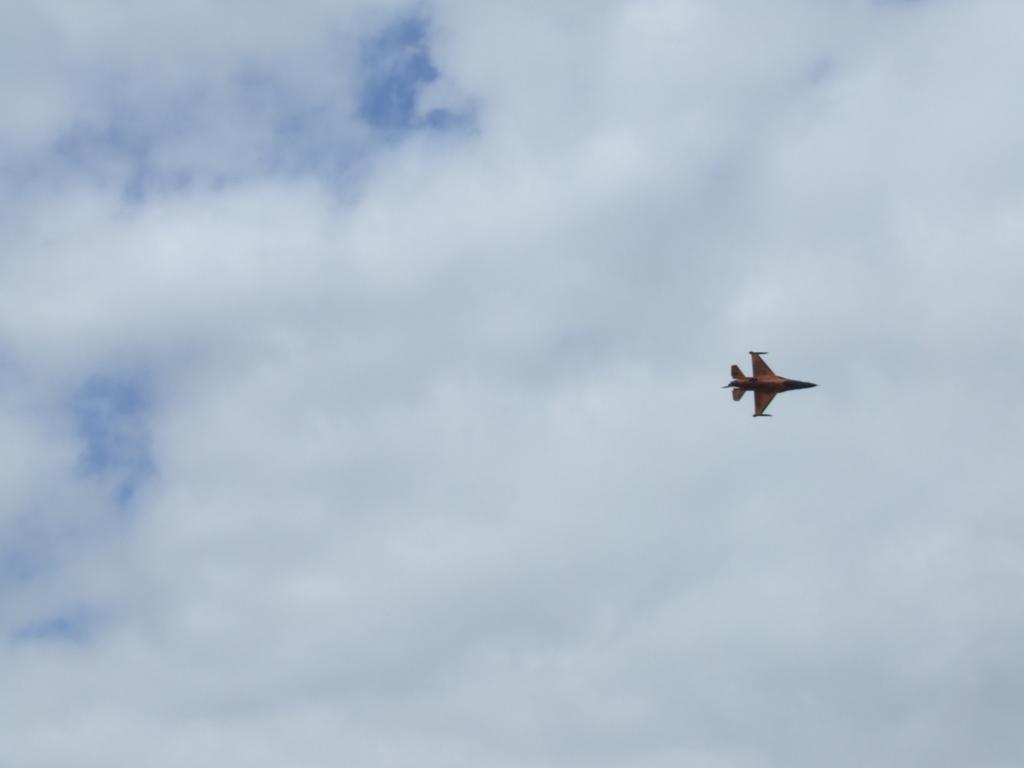What is the main subject of the image? The main subject of the image is an aeroplane. What is the aeroplane doing in the image? The aeroplane is flying in the air. What can be seen in the background of the image? There is sky visible in the background of the image. What is present in the sky? Clouds are present in the sky. What type of hat is the aeroplane wearing in the image? There is no hat present in the image, as aeroplanes do not wear hats. 